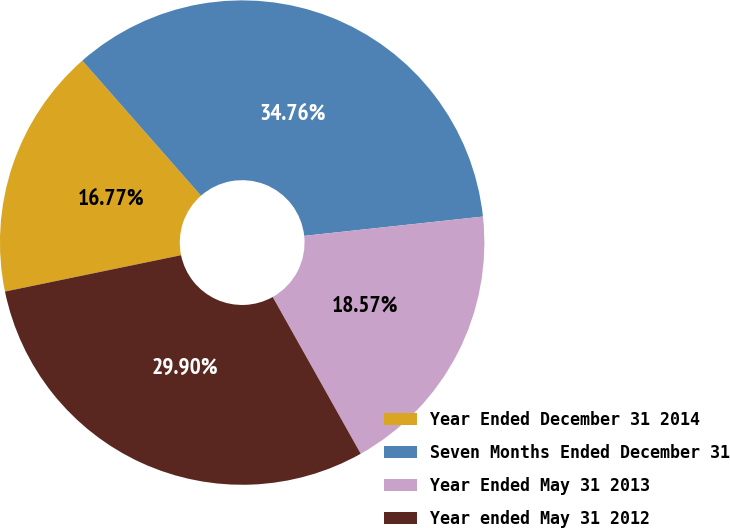<chart> <loc_0><loc_0><loc_500><loc_500><pie_chart><fcel>Year Ended December 31 2014<fcel>Seven Months Ended December 31<fcel>Year Ended May 31 2013<fcel>Year ended May 31 2012<nl><fcel>16.77%<fcel>34.76%<fcel>18.57%<fcel>29.9%<nl></chart> 